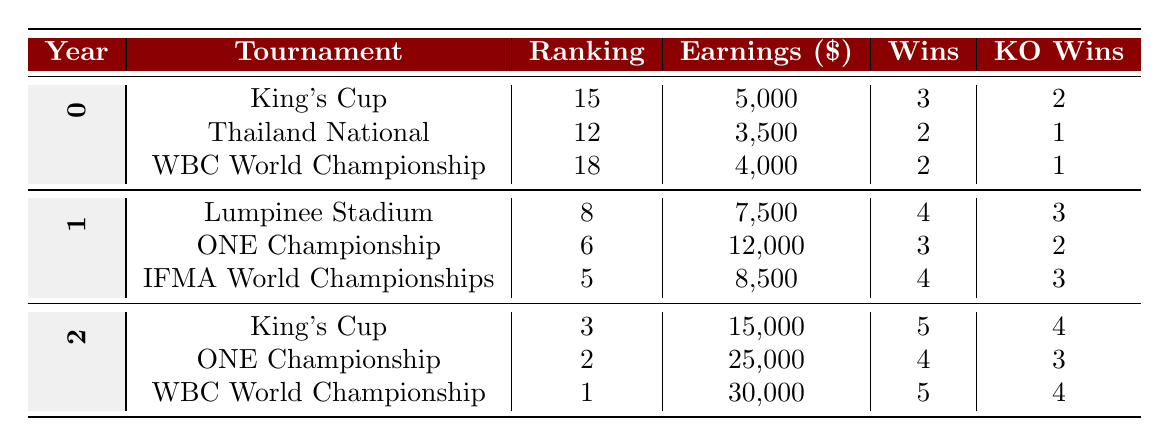What was the highest earnings in 2022? In the year 2022, there are three tournaments listed: King's Cup (15,000), ONE Championship (25,000), and WBC World Championship (30,000). The highest earnings among these tournaments is 30,000 from the WBC World Championship.
Answer: 30,000 How many wins did you have in total for 2021? The wins for each tournament in 2021 are: Lumpinee Stadium (4), ONE Championship (3), and IFMA World Championships (4). Summing these gives: 4 + 3 + 4 = 11 wins in total for 2021.
Answer: 11 Did you earn more in 2021 than in 2020? The total earnings for 2020 were 5,000 + 3,500 + 4,000 = 12,500, while for 2021 the total earnings were 7,500 + 12,000 + 8,500 = 28,000. Since 28,000 is greater than 12,500, the answer is yes.
Answer: Yes What is the average ranking across all tournaments in 2022? The rankings in 2022 are: 3 (King's Cup), 2 (ONE Championship), and 1 (WBC World Championship). To find the average, sum these rankings: 3 + 2 + 1 = 6, and divide by the number of tournaments (3): 6 / 3 = 2.
Answer: 2 Which tournament had the most knockout wins in 2021? In 2021, the knockout wins were: Lumpinee Stadium (3), ONE Championship (2), and IFMA World Championships (3). Both Lumpinee Stadium and IFMA World Championships had the most knockout wins, with 3 each, thus there are two tournaments tied.
Answer: Lumpinee Stadium and IFMA World Championships What was your ranking improvement from 2020 to 2022 for the King's Cup tournament? In 2020, the ranking for the King's Cup was 15, and in 2022 it improved to 3. The improvement can be calculated by subtracting: 15 - 3 = 12. Thus, it shows an improvement of 12 ranking positions.
Answer: 12 Were there any losses in 2021 at the IFMA World Championships? According to the data, the IFMA World Championships listed in 2021 shows 0 losses. Since there were no reported losses, the answer is no.
Answer: No What was the change in earnings from 2020 to 2021? The total earnings for 2020 were 12,500 (5,000 + 3,500 + 4,000), and for 2021, the total was 28,000 (7,500 + 12,000 + 8,500). The change can be calculated as: 28,000 - 12,500 = 15,500.
Answer: 15,500 What is the total number of fights won across all tournaments in 2020? The wins for each tournament in 2020 are: King's Cup (3), Thailand National (2), and WBC World Championship (2). Summing these gives: 3 + 2 + 2 = 7 total wins in 2020.
Answer: 7 